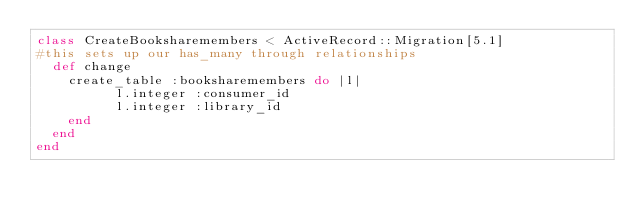<code> <loc_0><loc_0><loc_500><loc_500><_Ruby_>class CreateBooksharemembers < ActiveRecord::Migration[5.1]
#this sets up our has_many through relationships
  def change
    create_table :booksharemembers do |l|
          l.integer :consumer_id
          l.integer :library_id
    end
  end
end
</code> 